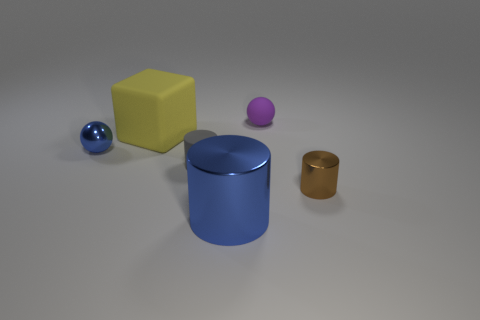What is the size of the blue cylinder that is the same material as the small brown thing?
Your answer should be very brief. Large. What shape is the tiny rubber object that is right of the gray thing in front of the sphere that is on the right side of the metallic ball?
Provide a short and direct response. Sphere. Are there the same number of large matte things that are on the right side of the small purple matte object and tiny brown cylinders?
Keep it short and to the point. No. The object that is the same color as the large shiny cylinder is what size?
Give a very brief answer. Small. Does the tiny gray matte thing have the same shape as the purple rubber thing?
Offer a very short reply. No. What number of things are things in front of the small blue ball or big cylinders?
Offer a very short reply. 3. Are there the same number of blue shiny things that are in front of the blue metallic ball and blue things that are in front of the brown cylinder?
Provide a short and direct response. Yes. How many other things are the same shape as the large blue metallic thing?
Your response must be concise. 2. There is a blue metallic thing that is on the right side of the tiny blue sphere; does it have the same size as the matte object behind the yellow thing?
Keep it short and to the point. No. What number of spheres are either yellow matte things or big blue objects?
Your answer should be compact. 0. 